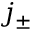Convert formula to latex. <formula><loc_0><loc_0><loc_500><loc_500>j _ { \pm }</formula> 